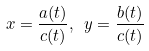Convert formula to latex. <formula><loc_0><loc_0><loc_500><loc_500>x = \frac { a ( t ) } { c ( t ) } , \ y = \frac { b ( t ) } { c ( t ) }</formula> 